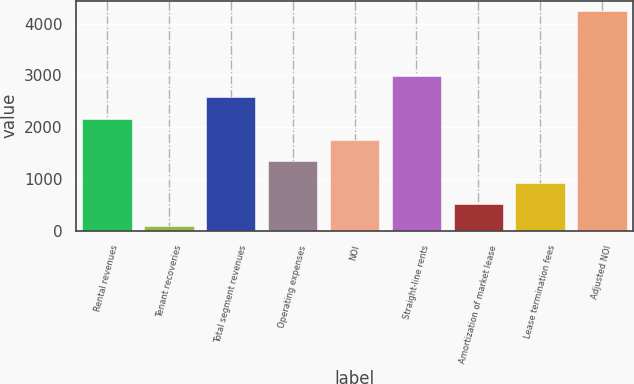Convert chart to OTSL. <chart><loc_0><loc_0><loc_500><loc_500><bar_chart><fcel>Rental revenues<fcel>Tenant recoveries<fcel>Total segment revenues<fcel>Operating expenses<fcel>NOI<fcel>Straight-line rents<fcel>Amortization of market lease<fcel>Lease termination fees<fcel>Adjusted NOI<nl><fcel>2168<fcel>104<fcel>2580.8<fcel>1342.4<fcel>1755.2<fcel>2993.6<fcel>516.8<fcel>929.6<fcel>4232<nl></chart> 